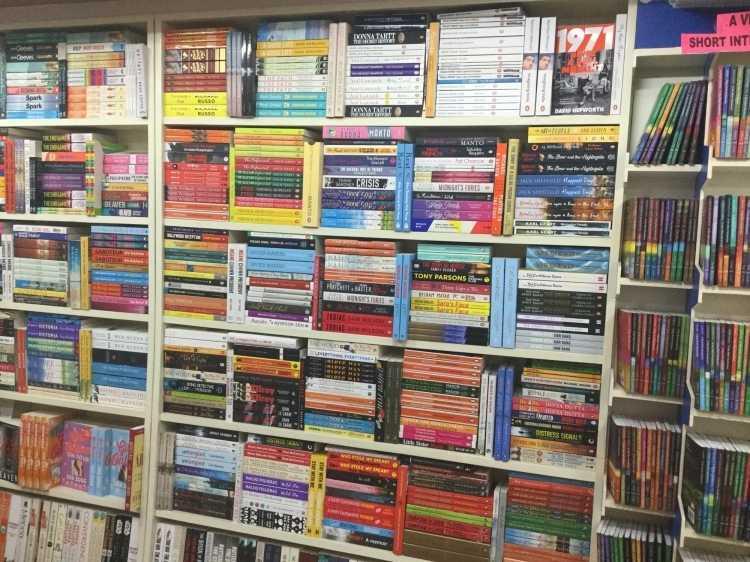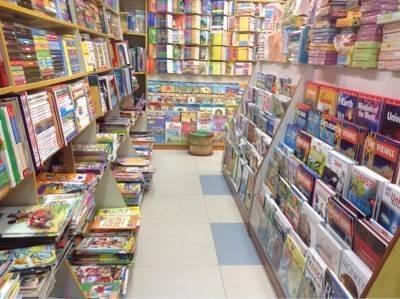The first image is the image on the left, the second image is the image on the right. For the images shown, is this caption "The exterior of a bookshop with plate glass windows is seen in one image, while a second image shows interior racks of books." true? Answer yes or no. No. The first image is the image on the left, the second image is the image on the right. For the images shown, is this caption "One image is taken from outside the shop." true? Answer yes or no. No. 